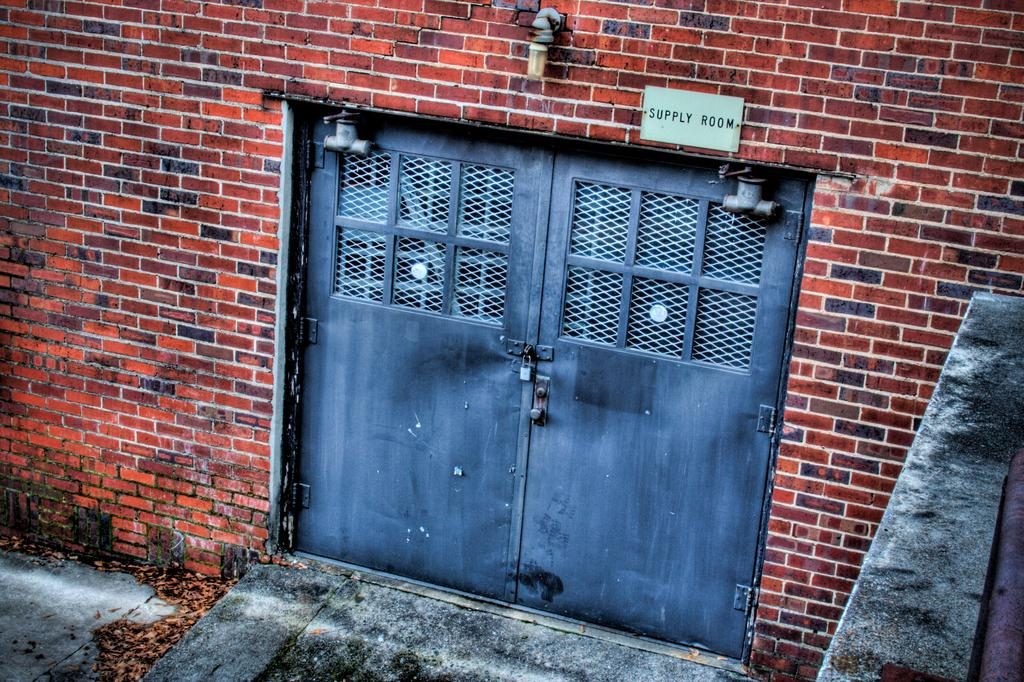What is the main subject of the image? The main subject of the image is the door of a building. Are there any additional objects or features in the image? Yes, there is a poster and a light attached to the wall in the image. How does the crowd react to the airplane in the image? There is no crowd or airplane present in the image. 